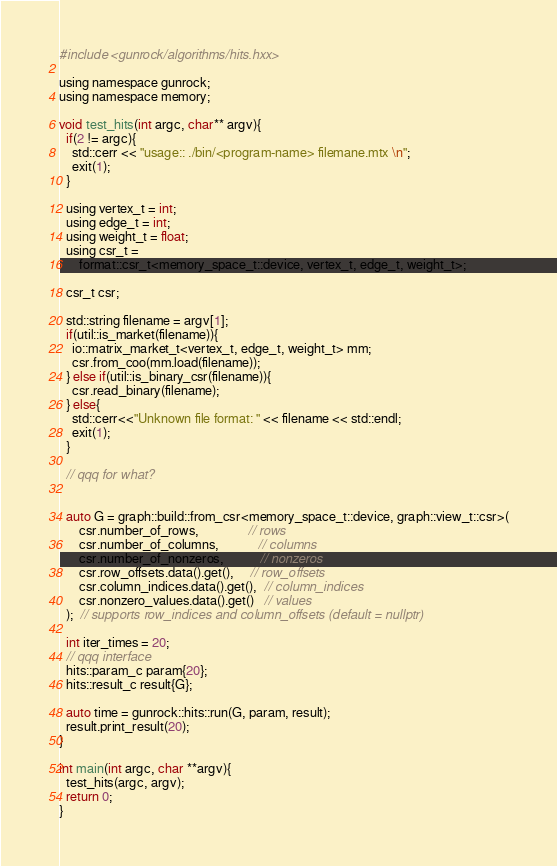<code> <loc_0><loc_0><loc_500><loc_500><_Cuda_>#include <gunrock/algorithms/hits.hxx>

using namespace gunrock;
using namespace memory;

void test_hits(int argc, char** argv){
  if(2 != argc){
    std::cerr << "usage:: ./bin/<program-name> filemane.mtx \n";
    exit(1);
  }

  using vertex_t = int;
  using edge_t = int;
  using weight_t = float;
  using csr_t =
      format::csr_t<memory_space_t::device, vertex_t, edge_t, weight_t>;

  csr_t csr;

  std::string filename = argv[1];
  if(util::is_market(filename)){
    io::matrix_market_t<vertex_t, edge_t, weight_t> mm;
    csr.from_coo(mm.load(filename));
  } else if(util::is_binary_csr(filename)){
    csr.read_binary(filename);
  } else{
    std::cerr<<"Unknown file format: " << filename << std::endl;
    exit(1);
  }

  // qqq for what?


  auto G = graph::build::from_csr<memory_space_t::device, graph::view_t::csr>(
      csr.number_of_rows,               // rows
      csr.number_of_columns,            // columns
      csr.number_of_nonzeros,           // nonzeros
      csr.row_offsets.data().get(),     // row_offsets
      csr.column_indices.data().get(),  // column_indices
      csr.nonzero_values.data().get()   // values
  );  // supports row_indices and column_offsets (default = nullptr)

  int iter_times = 20;
  // qqq interface
  hits::param_c param{20};
  hits::result_c result{G};

  auto time = gunrock::hits::run(G, param, result);
  result.print_result(20);
}

int main(int argc, char **argv){
  test_hits(argc, argv);
  return 0;
}
</code> 